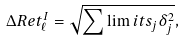<formula> <loc_0><loc_0><loc_500><loc_500>\Delta R e t ^ { I } _ { \ell } = \sqrt { \sum \lim i t s _ { j } \delta _ { j } ^ { 2 } } ,</formula> 